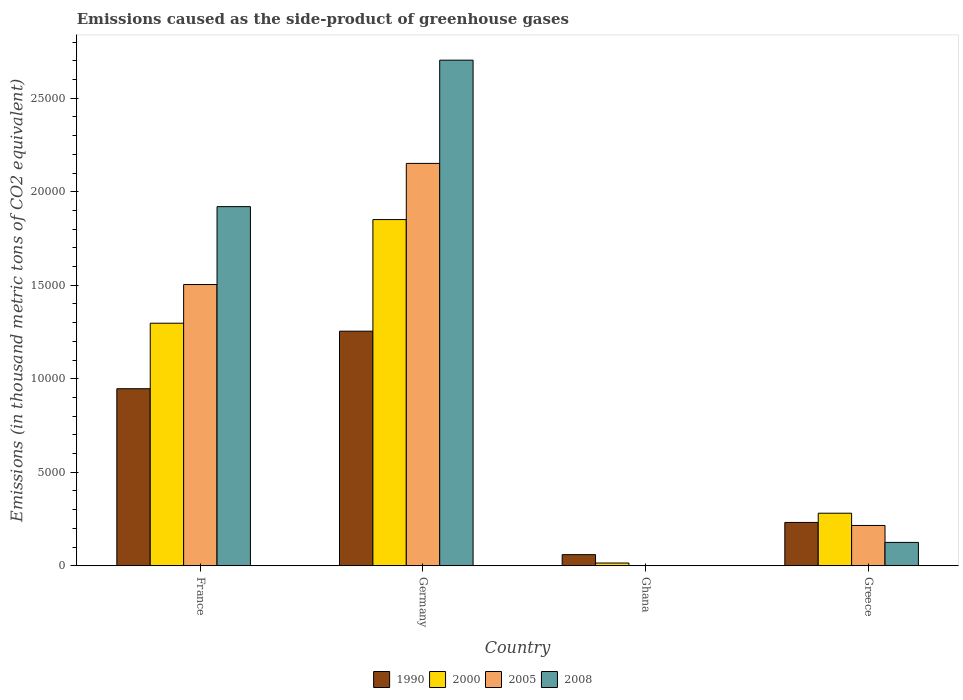Are the number of bars per tick equal to the number of legend labels?
Provide a succinct answer. Yes. How many bars are there on the 4th tick from the left?
Your answer should be very brief. 4. In how many cases, is the number of bars for a given country not equal to the number of legend labels?
Provide a succinct answer. 0. What is the emissions caused as the side-product of greenhouse gases in 1990 in Germany?
Your answer should be very brief. 1.25e+04. Across all countries, what is the maximum emissions caused as the side-product of greenhouse gases in 2000?
Provide a short and direct response. 1.85e+04. Across all countries, what is the minimum emissions caused as the side-product of greenhouse gases in 2005?
Provide a succinct answer. 14.7. In which country was the emissions caused as the side-product of greenhouse gases in 2005 maximum?
Your answer should be compact. Germany. In which country was the emissions caused as the side-product of greenhouse gases in 2008 minimum?
Your response must be concise. Ghana. What is the total emissions caused as the side-product of greenhouse gases in 1990 in the graph?
Offer a terse response. 2.49e+04. What is the difference between the emissions caused as the side-product of greenhouse gases in 1990 in Germany and that in Ghana?
Your answer should be compact. 1.19e+04. What is the difference between the emissions caused as the side-product of greenhouse gases in 2005 in France and the emissions caused as the side-product of greenhouse gases in 2008 in Germany?
Your answer should be very brief. -1.20e+04. What is the average emissions caused as the side-product of greenhouse gases in 2000 per country?
Offer a terse response. 8611.15. What is the difference between the emissions caused as the side-product of greenhouse gases of/in 1990 and emissions caused as the side-product of greenhouse gases of/in 2008 in Ghana?
Keep it short and to the point. 585. In how many countries, is the emissions caused as the side-product of greenhouse gases in 2005 greater than 19000 thousand metric tons?
Make the answer very short. 1. What is the ratio of the emissions caused as the side-product of greenhouse gases in 2005 in France to that in Ghana?
Make the answer very short. 1023.07. Is the difference between the emissions caused as the side-product of greenhouse gases in 1990 in France and Greece greater than the difference between the emissions caused as the side-product of greenhouse gases in 2008 in France and Greece?
Your answer should be compact. No. What is the difference between the highest and the second highest emissions caused as the side-product of greenhouse gases in 1990?
Make the answer very short. 3077.5. What is the difference between the highest and the lowest emissions caused as the side-product of greenhouse gases in 2000?
Provide a short and direct response. 1.84e+04. Is the sum of the emissions caused as the side-product of greenhouse gases in 1990 in Ghana and Greece greater than the maximum emissions caused as the side-product of greenhouse gases in 2000 across all countries?
Give a very brief answer. No. Is it the case that in every country, the sum of the emissions caused as the side-product of greenhouse gases in 2000 and emissions caused as the side-product of greenhouse gases in 2005 is greater than the sum of emissions caused as the side-product of greenhouse gases in 1990 and emissions caused as the side-product of greenhouse gases in 2008?
Offer a very short reply. No. What does the 3rd bar from the right in Ghana represents?
Offer a terse response. 2000. Is it the case that in every country, the sum of the emissions caused as the side-product of greenhouse gases in 2005 and emissions caused as the side-product of greenhouse gases in 2008 is greater than the emissions caused as the side-product of greenhouse gases in 2000?
Provide a succinct answer. No. How many bars are there?
Your response must be concise. 16. Are all the bars in the graph horizontal?
Offer a very short reply. No. How many countries are there in the graph?
Keep it short and to the point. 4. Are the values on the major ticks of Y-axis written in scientific E-notation?
Provide a short and direct response. No. Does the graph contain any zero values?
Ensure brevity in your answer.  No. Does the graph contain grids?
Your answer should be very brief. No. What is the title of the graph?
Ensure brevity in your answer.  Emissions caused as the side-product of greenhouse gases. What is the label or title of the Y-axis?
Your response must be concise. Emissions (in thousand metric tons of CO2 equivalent). What is the Emissions (in thousand metric tons of CO2 equivalent) in 1990 in France?
Give a very brief answer. 9468.2. What is the Emissions (in thousand metric tons of CO2 equivalent) in 2000 in France?
Ensure brevity in your answer.  1.30e+04. What is the Emissions (in thousand metric tons of CO2 equivalent) in 2005 in France?
Offer a terse response. 1.50e+04. What is the Emissions (in thousand metric tons of CO2 equivalent) of 2008 in France?
Keep it short and to the point. 1.92e+04. What is the Emissions (in thousand metric tons of CO2 equivalent) in 1990 in Germany?
Your response must be concise. 1.25e+04. What is the Emissions (in thousand metric tons of CO2 equivalent) in 2000 in Germany?
Offer a terse response. 1.85e+04. What is the Emissions (in thousand metric tons of CO2 equivalent) of 2005 in Germany?
Ensure brevity in your answer.  2.15e+04. What is the Emissions (in thousand metric tons of CO2 equivalent) in 2008 in Germany?
Provide a succinct answer. 2.70e+04. What is the Emissions (in thousand metric tons of CO2 equivalent) in 1990 in Ghana?
Your response must be concise. 596.2. What is the Emissions (in thousand metric tons of CO2 equivalent) in 2000 in Ghana?
Ensure brevity in your answer.  148. What is the Emissions (in thousand metric tons of CO2 equivalent) in 2005 in Ghana?
Make the answer very short. 14.7. What is the Emissions (in thousand metric tons of CO2 equivalent) of 1990 in Greece?
Your answer should be compact. 2318.5. What is the Emissions (in thousand metric tons of CO2 equivalent) in 2000 in Greece?
Your answer should be compact. 2811.5. What is the Emissions (in thousand metric tons of CO2 equivalent) in 2005 in Greece?
Make the answer very short. 2157. What is the Emissions (in thousand metric tons of CO2 equivalent) of 2008 in Greece?
Offer a very short reply. 1250.2. Across all countries, what is the maximum Emissions (in thousand metric tons of CO2 equivalent) in 1990?
Your response must be concise. 1.25e+04. Across all countries, what is the maximum Emissions (in thousand metric tons of CO2 equivalent) in 2000?
Give a very brief answer. 1.85e+04. Across all countries, what is the maximum Emissions (in thousand metric tons of CO2 equivalent) in 2005?
Keep it short and to the point. 2.15e+04. Across all countries, what is the maximum Emissions (in thousand metric tons of CO2 equivalent) of 2008?
Offer a terse response. 2.70e+04. Across all countries, what is the minimum Emissions (in thousand metric tons of CO2 equivalent) of 1990?
Offer a very short reply. 596.2. Across all countries, what is the minimum Emissions (in thousand metric tons of CO2 equivalent) in 2000?
Keep it short and to the point. 148. Across all countries, what is the minimum Emissions (in thousand metric tons of CO2 equivalent) of 2005?
Offer a very short reply. 14.7. Across all countries, what is the minimum Emissions (in thousand metric tons of CO2 equivalent) of 2008?
Give a very brief answer. 11.2. What is the total Emissions (in thousand metric tons of CO2 equivalent) of 1990 in the graph?
Offer a very short reply. 2.49e+04. What is the total Emissions (in thousand metric tons of CO2 equivalent) in 2000 in the graph?
Offer a terse response. 3.44e+04. What is the total Emissions (in thousand metric tons of CO2 equivalent) of 2005 in the graph?
Your answer should be very brief. 3.87e+04. What is the total Emissions (in thousand metric tons of CO2 equivalent) in 2008 in the graph?
Your answer should be compact. 4.75e+04. What is the difference between the Emissions (in thousand metric tons of CO2 equivalent) in 1990 in France and that in Germany?
Provide a succinct answer. -3077.5. What is the difference between the Emissions (in thousand metric tons of CO2 equivalent) of 2000 in France and that in Germany?
Your answer should be compact. -5542.7. What is the difference between the Emissions (in thousand metric tons of CO2 equivalent) in 2005 in France and that in Germany?
Provide a short and direct response. -6478.3. What is the difference between the Emissions (in thousand metric tons of CO2 equivalent) in 2008 in France and that in Germany?
Your answer should be compact. -7832.8. What is the difference between the Emissions (in thousand metric tons of CO2 equivalent) of 1990 in France and that in Ghana?
Offer a terse response. 8872. What is the difference between the Emissions (in thousand metric tons of CO2 equivalent) in 2000 in France and that in Ghana?
Make the answer very short. 1.28e+04. What is the difference between the Emissions (in thousand metric tons of CO2 equivalent) in 2005 in France and that in Ghana?
Your response must be concise. 1.50e+04. What is the difference between the Emissions (in thousand metric tons of CO2 equivalent) of 2008 in France and that in Ghana?
Make the answer very short. 1.92e+04. What is the difference between the Emissions (in thousand metric tons of CO2 equivalent) in 1990 in France and that in Greece?
Your response must be concise. 7149.7. What is the difference between the Emissions (in thousand metric tons of CO2 equivalent) of 2000 in France and that in Greece?
Provide a succinct answer. 1.02e+04. What is the difference between the Emissions (in thousand metric tons of CO2 equivalent) of 2005 in France and that in Greece?
Your response must be concise. 1.29e+04. What is the difference between the Emissions (in thousand metric tons of CO2 equivalent) in 2008 in France and that in Greece?
Give a very brief answer. 1.80e+04. What is the difference between the Emissions (in thousand metric tons of CO2 equivalent) in 1990 in Germany and that in Ghana?
Your answer should be very brief. 1.19e+04. What is the difference between the Emissions (in thousand metric tons of CO2 equivalent) of 2000 in Germany and that in Ghana?
Give a very brief answer. 1.84e+04. What is the difference between the Emissions (in thousand metric tons of CO2 equivalent) of 2005 in Germany and that in Ghana?
Ensure brevity in your answer.  2.15e+04. What is the difference between the Emissions (in thousand metric tons of CO2 equivalent) in 2008 in Germany and that in Ghana?
Ensure brevity in your answer.  2.70e+04. What is the difference between the Emissions (in thousand metric tons of CO2 equivalent) in 1990 in Germany and that in Greece?
Provide a succinct answer. 1.02e+04. What is the difference between the Emissions (in thousand metric tons of CO2 equivalent) of 2000 in Germany and that in Greece?
Ensure brevity in your answer.  1.57e+04. What is the difference between the Emissions (in thousand metric tons of CO2 equivalent) in 2005 in Germany and that in Greece?
Your response must be concise. 1.94e+04. What is the difference between the Emissions (in thousand metric tons of CO2 equivalent) in 2008 in Germany and that in Greece?
Your answer should be compact. 2.58e+04. What is the difference between the Emissions (in thousand metric tons of CO2 equivalent) of 1990 in Ghana and that in Greece?
Your answer should be very brief. -1722.3. What is the difference between the Emissions (in thousand metric tons of CO2 equivalent) in 2000 in Ghana and that in Greece?
Your answer should be very brief. -2663.5. What is the difference between the Emissions (in thousand metric tons of CO2 equivalent) in 2005 in Ghana and that in Greece?
Offer a terse response. -2142.3. What is the difference between the Emissions (in thousand metric tons of CO2 equivalent) of 2008 in Ghana and that in Greece?
Offer a terse response. -1239. What is the difference between the Emissions (in thousand metric tons of CO2 equivalent) of 1990 in France and the Emissions (in thousand metric tons of CO2 equivalent) of 2000 in Germany?
Your answer should be compact. -9045.7. What is the difference between the Emissions (in thousand metric tons of CO2 equivalent) in 1990 in France and the Emissions (in thousand metric tons of CO2 equivalent) in 2005 in Germany?
Keep it short and to the point. -1.20e+04. What is the difference between the Emissions (in thousand metric tons of CO2 equivalent) of 1990 in France and the Emissions (in thousand metric tons of CO2 equivalent) of 2008 in Germany?
Your answer should be compact. -1.76e+04. What is the difference between the Emissions (in thousand metric tons of CO2 equivalent) in 2000 in France and the Emissions (in thousand metric tons of CO2 equivalent) in 2005 in Germany?
Offer a very short reply. -8546.3. What is the difference between the Emissions (in thousand metric tons of CO2 equivalent) in 2000 in France and the Emissions (in thousand metric tons of CO2 equivalent) in 2008 in Germany?
Your answer should be very brief. -1.41e+04. What is the difference between the Emissions (in thousand metric tons of CO2 equivalent) of 2005 in France and the Emissions (in thousand metric tons of CO2 equivalent) of 2008 in Germany?
Your response must be concise. -1.20e+04. What is the difference between the Emissions (in thousand metric tons of CO2 equivalent) of 1990 in France and the Emissions (in thousand metric tons of CO2 equivalent) of 2000 in Ghana?
Your response must be concise. 9320.2. What is the difference between the Emissions (in thousand metric tons of CO2 equivalent) in 1990 in France and the Emissions (in thousand metric tons of CO2 equivalent) in 2005 in Ghana?
Give a very brief answer. 9453.5. What is the difference between the Emissions (in thousand metric tons of CO2 equivalent) in 1990 in France and the Emissions (in thousand metric tons of CO2 equivalent) in 2008 in Ghana?
Your answer should be compact. 9457. What is the difference between the Emissions (in thousand metric tons of CO2 equivalent) of 2000 in France and the Emissions (in thousand metric tons of CO2 equivalent) of 2005 in Ghana?
Keep it short and to the point. 1.30e+04. What is the difference between the Emissions (in thousand metric tons of CO2 equivalent) of 2000 in France and the Emissions (in thousand metric tons of CO2 equivalent) of 2008 in Ghana?
Make the answer very short. 1.30e+04. What is the difference between the Emissions (in thousand metric tons of CO2 equivalent) of 2005 in France and the Emissions (in thousand metric tons of CO2 equivalent) of 2008 in Ghana?
Keep it short and to the point. 1.50e+04. What is the difference between the Emissions (in thousand metric tons of CO2 equivalent) of 1990 in France and the Emissions (in thousand metric tons of CO2 equivalent) of 2000 in Greece?
Give a very brief answer. 6656.7. What is the difference between the Emissions (in thousand metric tons of CO2 equivalent) in 1990 in France and the Emissions (in thousand metric tons of CO2 equivalent) in 2005 in Greece?
Make the answer very short. 7311.2. What is the difference between the Emissions (in thousand metric tons of CO2 equivalent) in 1990 in France and the Emissions (in thousand metric tons of CO2 equivalent) in 2008 in Greece?
Your response must be concise. 8218. What is the difference between the Emissions (in thousand metric tons of CO2 equivalent) in 2000 in France and the Emissions (in thousand metric tons of CO2 equivalent) in 2005 in Greece?
Your answer should be compact. 1.08e+04. What is the difference between the Emissions (in thousand metric tons of CO2 equivalent) in 2000 in France and the Emissions (in thousand metric tons of CO2 equivalent) in 2008 in Greece?
Make the answer very short. 1.17e+04. What is the difference between the Emissions (in thousand metric tons of CO2 equivalent) of 2005 in France and the Emissions (in thousand metric tons of CO2 equivalent) of 2008 in Greece?
Make the answer very short. 1.38e+04. What is the difference between the Emissions (in thousand metric tons of CO2 equivalent) of 1990 in Germany and the Emissions (in thousand metric tons of CO2 equivalent) of 2000 in Ghana?
Keep it short and to the point. 1.24e+04. What is the difference between the Emissions (in thousand metric tons of CO2 equivalent) of 1990 in Germany and the Emissions (in thousand metric tons of CO2 equivalent) of 2005 in Ghana?
Give a very brief answer. 1.25e+04. What is the difference between the Emissions (in thousand metric tons of CO2 equivalent) of 1990 in Germany and the Emissions (in thousand metric tons of CO2 equivalent) of 2008 in Ghana?
Your answer should be very brief. 1.25e+04. What is the difference between the Emissions (in thousand metric tons of CO2 equivalent) in 2000 in Germany and the Emissions (in thousand metric tons of CO2 equivalent) in 2005 in Ghana?
Your response must be concise. 1.85e+04. What is the difference between the Emissions (in thousand metric tons of CO2 equivalent) of 2000 in Germany and the Emissions (in thousand metric tons of CO2 equivalent) of 2008 in Ghana?
Provide a succinct answer. 1.85e+04. What is the difference between the Emissions (in thousand metric tons of CO2 equivalent) in 2005 in Germany and the Emissions (in thousand metric tons of CO2 equivalent) in 2008 in Ghana?
Your answer should be very brief. 2.15e+04. What is the difference between the Emissions (in thousand metric tons of CO2 equivalent) of 1990 in Germany and the Emissions (in thousand metric tons of CO2 equivalent) of 2000 in Greece?
Offer a terse response. 9734.2. What is the difference between the Emissions (in thousand metric tons of CO2 equivalent) in 1990 in Germany and the Emissions (in thousand metric tons of CO2 equivalent) in 2005 in Greece?
Provide a short and direct response. 1.04e+04. What is the difference between the Emissions (in thousand metric tons of CO2 equivalent) in 1990 in Germany and the Emissions (in thousand metric tons of CO2 equivalent) in 2008 in Greece?
Your answer should be very brief. 1.13e+04. What is the difference between the Emissions (in thousand metric tons of CO2 equivalent) in 2000 in Germany and the Emissions (in thousand metric tons of CO2 equivalent) in 2005 in Greece?
Provide a succinct answer. 1.64e+04. What is the difference between the Emissions (in thousand metric tons of CO2 equivalent) in 2000 in Germany and the Emissions (in thousand metric tons of CO2 equivalent) in 2008 in Greece?
Keep it short and to the point. 1.73e+04. What is the difference between the Emissions (in thousand metric tons of CO2 equivalent) of 2005 in Germany and the Emissions (in thousand metric tons of CO2 equivalent) of 2008 in Greece?
Ensure brevity in your answer.  2.03e+04. What is the difference between the Emissions (in thousand metric tons of CO2 equivalent) in 1990 in Ghana and the Emissions (in thousand metric tons of CO2 equivalent) in 2000 in Greece?
Offer a very short reply. -2215.3. What is the difference between the Emissions (in thousand metric tons of CO2 equivalent) of 1990 in Ghana and the Emissions (in thousand metric tons of CO2 equivalent) of 2005 in Greece?
Your response must be concise. -1560.8. What is the difference between the Emissions (in thousand metric tons of CO2 equivalent) of 1990 in Ghana and the Emissions (in thousand metric tons of CO2 equivalent) of 2008 in Greece?
Make the answer very short. -654. What is the difference between the Emissions (in thousand metric tons of CO2 equivalent) in 2000 in Ghana and the Emissions (in thousand metric tons of CO2 equivalent) in 2005 in Greece?
Give a very brief answer. -2009. What is the difference between the Emissions (in thousand metric tons of CO2 equivalent) in 2000 in Ghana and the Emissions (in thousand metric tons of CO2 equivalent) in 2008 in Greece?
Your answer should be compact. -1102.2. What is the difference between the Emissions (in thousand metric tons of CO2 equivalent) in 2005 in Ghana and the Emissions (in thousand metric tons of CO2 equivalent) in 2008 in Greece?
Your response must be concise. -1235.5. What is the average Emissions (in thousand metric tons of CO2 equivalent) in 1990 per country?
Keep it short and to the point. 6232.15. What is the average Emissions (in thousand metric tons of CO2 equivalent) in 2000 per country?
Offer a very short reply. 8611.15. What is the average Emissions (in thousand metric tons of CO2 equivalent) in 2005 per country?
Offer a very short reply. 9682.1. What is the average Emissions (in thousand metric tons of CO2 equivalent) in 2008 per country?
Make the answer very short. 1.19e+04. What is the difference between the Emissions (in thousand metric tons of CO2 equivalent) in 1990 and Emissions (in thousand metric tons of CO2 equivalent) in 2000 in France?
Ensure brevity in your answer.  -3503. What is the difference between the Emissions (in thousand metric tons of CO2 equivalent) in 1990 and Emissions (in thousand metric tons of CO2 equivalent) in 2005 in France?
Your answer should be very brief. -5571. What is the difference between the Emissions (in thousand metric tons of CO2 equivalent) in 1990 and Emissions (in thousand metric tons of CO2 equivalent) in 2008 in France?
Your response must be concise. -9736.8. What is the difference between the Emissions (in thousand metric tons of CO2 equivalent) in 2000 and Emissions (in thousand metric tons of CO2 equivalent) in 2005 in France?
Provide a short and direct response. -2068. What is the difference between the Emissions (in thousand metric tons of CO2 equivalent) of 2000 and Emissions (in thousand metric tons of CO2 equivalent) of 2008 in France?
Provide a succinct answer. -6233.8. What is the difference between the Emissions (in thousand metric tons of CO2 equivalent) of 2005 and Emissions (in thousand metric tons of CO2 equivalent) of 2008 in France?
Give a very brief answer. -4165.8. What is the difference between the Emissions (in thousand metric tons of CO2 equivalent) in 1990 and Emissions (in thousand metric tons of CO2 equivalent) in 2000 in Germany?
Give a very brief answer. -5968.2. What is the difference between the Emissions (in thousand metric tons of CO2 equivalent) of 1990 and Emissions (in thousand metric tons of CO2 equivalent) of 2005 in Germany?
Your answer should be very brief. -8971.8. What is the difference between the Emissions (in thousand metric tons of CO2 equivalent) of 1990 and Emissions (in thousand metric tons of CO2 equivalent) of 2008 in Germany?
Keep it short and to the point. -1.45e+04. What is the difference between the Emissions (in thousand metric tons of CO2 equivalent) of 2000 and Emissions (in thousand metric tons of CO2 equivalent) of 2005 in Germany?
Ensure brevity in your answer.  -3003.6. What is the difference between the Emissions (in thousand metric tons of CO2 equivalent) in 2000 and Emissions (in thousand metric tons of CO2 equivalent) in 2008 in Germany?
Offer a very short reply. -8523.9. What is the difference between the Emissions (in thousand metric tons of CO2 equivalent) of 2005 and Emissions (in thousand metric tons of CO2 equivalent) of 2008 in Germany?
Offer a very short reply. -5520.3. What is the difference between the Emissions (in thousand metric tons of CO2 equivalent) in 1990 and Emissions (in thousand metric tons of CO2 equivalent) in 2000 in Ghana?
Keep it short and to the point. 448.2. What is the difference between the Emissions (in thousand metric tons of CO2 equivalent) in 1990 and Emissions (in thousand metric tons of CO2 equivalent) in 2005 in Ghana?
Your answer should be compact. 581.5. What is the difference between the Emissions (in thousand metric tons of CO2 equivalent) of 1990 and Emissions (in thousand metric tons of CO2 equivalent) of 2008 in Ghana?
Offer a very short reply. 585. What is the difference between the Emissions (in thousand metric tons of CO2 equivalent) of 2000 and Emissions (in thousand metric tons of CO2 equivalent) of 2005 in Ghana?
Offer a terse response. 133.3. What is the difference between the Emissions (in thousand metric tons of CO2 equivalent) of 2000 and Emissions (in thousand metric tons of CO2 equivalent) of 2008 in Ghana?
Make the answer very short. 136.8. What is the difference between the Emissions (in thousand metric tons of CO2 equivalent) in 2005 and Emissions (in thousand metric tons of CO2 equivalent) in 2008 in Ghana?
Give a very brief answer. 3.5. What is the difference between the Emissions (in thousand metric tons of CO2 equivalent) of 1990 and Emissions (in thousand metric tons of CO2 equivalent) of 2000 in Greece?
Give a very brief answer. -493. What is the difference between the Emissions (in thousand metric tons of CO2 equivalent) of 1990 and Emissions (in thousand metric tons of CO2 equivalent) of 2005 in Greece?
Keep it short and to the point. 161.5. What is the difference between the Emissions (in thousand metric tons of CO2 equivalent) of 1990 and Emissions (in thousand metric tons of CO2 equivalent) of 2008 in Greece?
Provide a succinct answer. 1068.3. What is the difference between the Emissions (in thousand metric tons of CO2 equivalent) of 2000 and Emissions (in thousand metric tons of CO2 equivalent) of 2005 in Greece?
Offer a terse response. 654.5. What is the difference between the Emissions (in thousand metric tons of CO2 equivalent) of 2000 and Emissions (in thousand metric tons of CO2 equivalent) of 2008 in Greece?
Give a very brief answer. 1561.3. What is the difference between the Emissions (in thousand metric tons of CO2 equivalent) of 2005 and Emissions (in thousand metric tons of CO2 equivalent) of 2008 in Greece?
Provide a short and direct response. 906.8. What is the ratio of the Emissions (in thousand metric tons of CO2 equivalent) of 1990 in France to that in Germany?
Your answer should be very brief. 0.75. What is the ratio of the Emissions (in thousand metric tons of CO2 equivalent) of 2000 in France to that in Germany?
Offer a very short reply. 0.7. What is the ratio of the Emissions (in thousand metric tons of CO2 equivalent) in 2005 in France to that in Germany?
Your answer should be compact. 0.7. What is the ratio of the Emissions (in thousand metric tons of CO2 equivalent) in 2008 in France to that in Germany?
Offer a terse response. 0.71. What is the ratio of the Emissions (in thousand metric tons of CO2 equivalent) of 1990 in France to that in Ghana?
Offer a terse response. 15.88. What is the ratio of the Emissions (in thousand metric tons of CO2 equivalent) in 2000 in France to that in Ghana?
Provide a succinct answer. 87.64. What is the ratio of the Emissions (in thousand metric tons of CO2 equivalent) in 2005 in France to that in Ghana?
Your answer should be compact. 1023.07. What is the ratio of the Emissions (in thousand metric tons of CO2 equivalent) in 2008 in France to that in Ghana?
Your response must be concise. 1714.73. What is the ratio of the Emissions (in thousand metric tons of CO2 equivalent) in 1990 in France to that in Greece?
Ensure brevity in your answer.  4.08. What is the ratio of the Emissions (in thousand metric tons of CO2 equivalent) in 2000 in France to that in Greece?
Your answer should be compact. 4.61. What is the ratio of the Emissions (in thousand metric tons of CO2 equivalent) in 2005 in France to that in Greece?
Ensure brevity in your answer.  6.97. What is the ratio of the Emissions (in thousand metric tons of CO2 equivalent) of 2008 in France to that in Greece?
Give a very brief answer. 15.36. What is the ratio of the Emissions (in thousand metric tons of CO2 equivalent) of 1990 in Germany to that in Ghana?
Your response must be concise. 21.04. What is the ratio of the Emissions (in thousand metric tons of CO2 equivalent) in 2000 in Germany to that in Ghana?
Keep it short and to the point. 125.09. What is the ratio of the Emissions (in thousand metric tons of CO2 equivalent) of 2005 in Germany to that in Ghana?
Your response must be concise. 1463.78. What is the ratio of the Emissions (in thousand metric tons of CO2 equivalent) of 2008 in Germany to that in Ghana?
Keep it short and to the point. 2414.09. What is the ratio of the Emissions (in thousand metric tons of CO2 equivalent) of 1990 in Germany to that in Greece?
Provide a short and direct response. 5.41. What is the ratio of the Emissions (in thousand metric tons of CO2 equivalent) in 2000 in Germany to that in Greece?
Your answer should be compact. 6.59. What is the ratio of the Emissions (in thousand metric tons of CO2 equivalent) in 2005 in Germany to that in Greece?
Offer a very short reply. 9.98. What is the ratio of the Emissions (in thousand metric tons of CO2 equivalent) of 2008 in Germany to that in Greece?
Ensure brevity in your answer.  21.63. What is the ratio of the Emissions (in thousand metric tons of CO2 equivalent) in 1990 in Ghana to that in Greece?
Ensure brevity in your answer.  0.26. What is the ratio of the Emissions (in thousand metric tons of CO2 equivalent) of 2000 in Ghana to that in Greece?
Your answer should be very brief. 0.05. What is the ratio of the Emissions (in thousand metric tons of CO2 equivalent) in 2005 in Ghana to that in Greece?
Make the answer very short. 0.01. What is the ratio of the Emissions (in thousand metric tons of CO2 equivalent) in 2008 in Ghana to that in Greece?
Your answer should be very brief. 0.01. What is the difference between the highest and the second highest Emissions (in thousand metric tons of CO2 equivalent) in 1990?
Your answer should be compact. 3077.5. What is the difference between the highest and the second highest Emissions (in thousand metric tons of CO2 equivalent) of 2000?
Your response must be concise. 5542.7. What is the difference between the highest and the second highest Emissions (in thousand metric tons of CO2 equivalent) in 2005?
Provide a succinct answer. 6478.3. What is the difference between the highest and the second highest Emissions (in thousand metric tons of CO2 equivalent) in 2008?
Make the answer very short. 7832.8. What is the difference between the highest and the lowest Emissions (in thousand metric tons of CO2 equivalent) in 1990?
Ensure brevity in your answer.  1.19e+04. What is the difference between the highest and the lowest Emissions (in thousand metric tons of CO2 equivalent) of 2000?
Offer a very short reply. 1.84e+04. What is the difference between the highest and the lowest Emissions (in thousand metric tons of CO2 equivalent) in 2005?
Make the answer very short. 2.15e+04. What is the difference between the highest and the lowest Emissions (in thousand metric tons of CO2 equivalent) in 2008?
Offer a very short reply. 2.70e+04. 